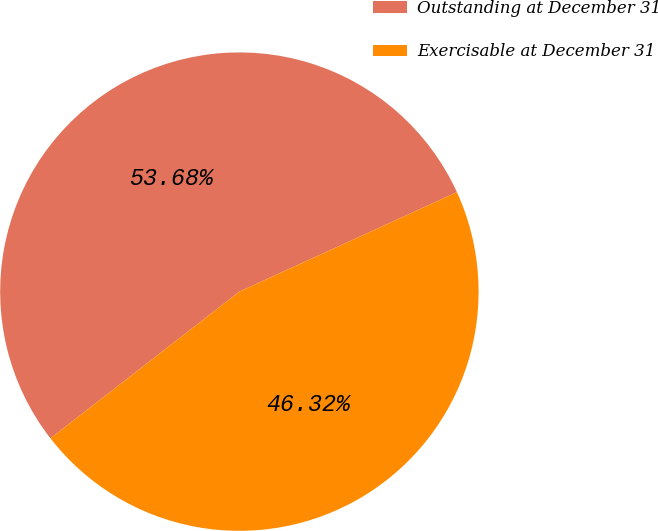<chart> <loc_0><loc_0><loc_500><loc_500><pie_chart><fcel>Outstanding at December 31<fcel>Exercisable at December 31<nl><fcel>53.68%<fcel>46.32%<nl></chart> 